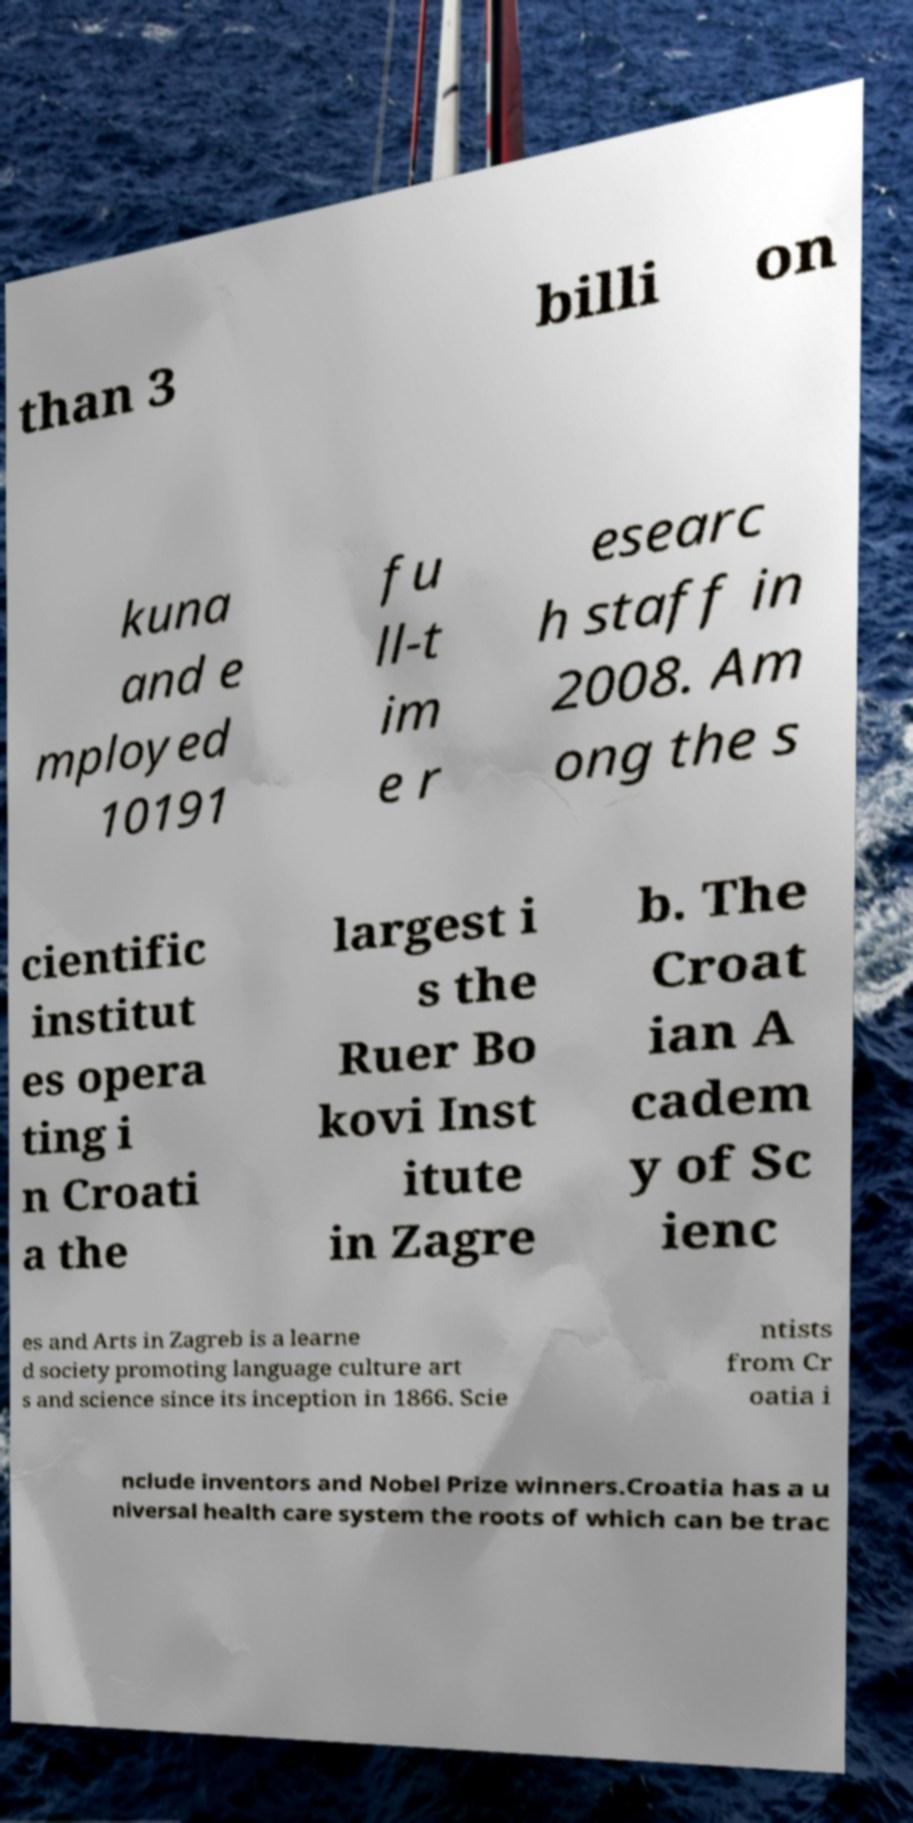I need the written content from this picture converted into text. Can you do that? than 3 billi on kuna and e mployed 10191 fu ll-t im e r esearc h staff in 2008. Am ong the s cientific institut es opera ting i n Croati a the largest i s the Ruer Bo kovi Inst itute in Zagre b. The Croat ian A cadem y of Sc ienc es and Arts in Zagreb is a learne d society promoting language culture art s and science since its inception in 1866. Scie ntists from Cr oatia i nclude inventors and Nobel Prize winners.Croatia has a u niversal health care system the roots of which can be trac 